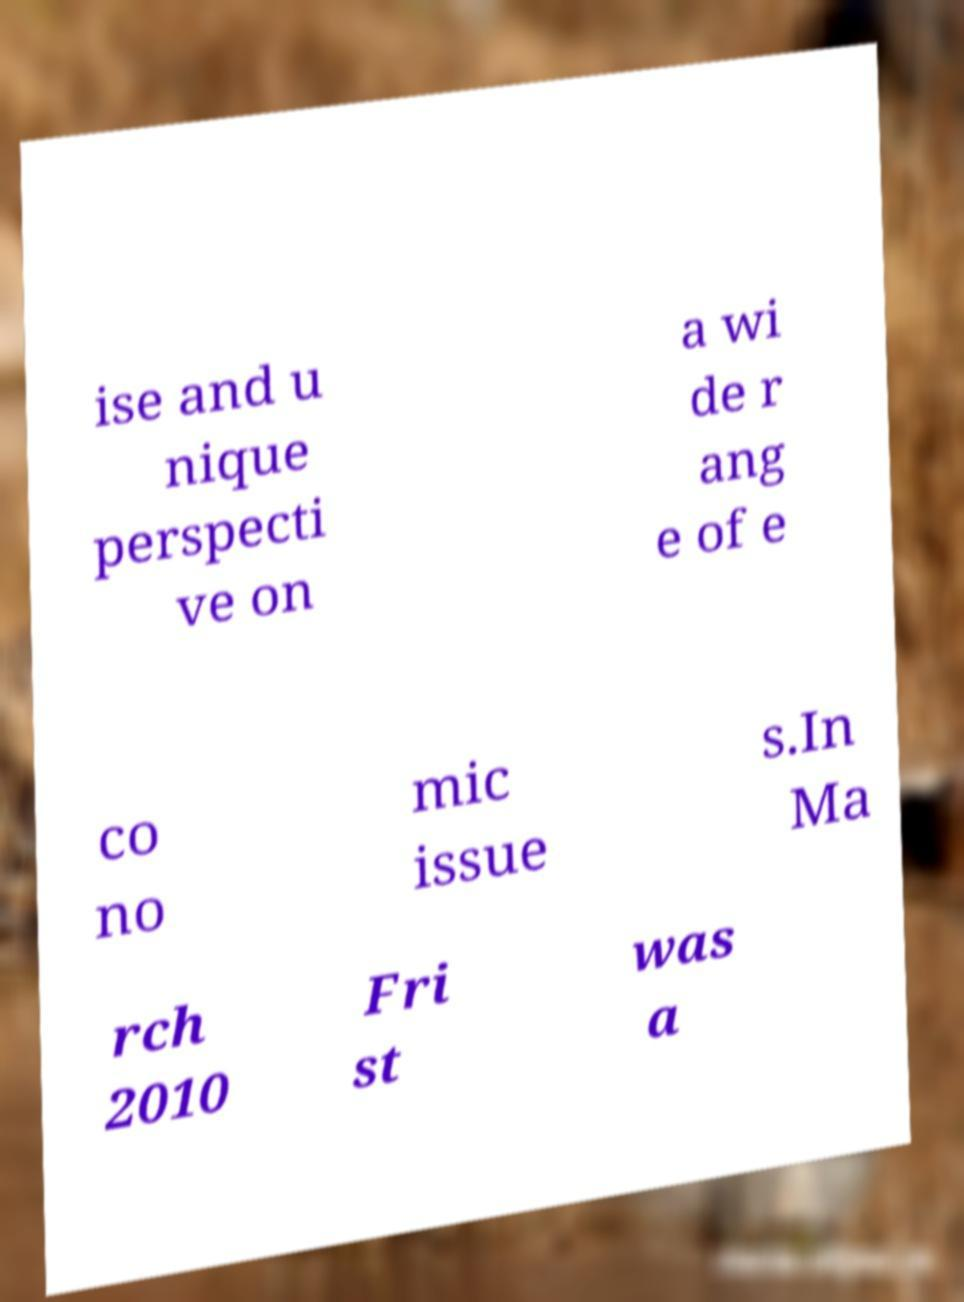Can you accurately transcribe the text from the provided image for me? ise and u nique perspecti ve on a wi de r ang e of e co no mic issue s.In Ma rch 2010 Fri st was a 